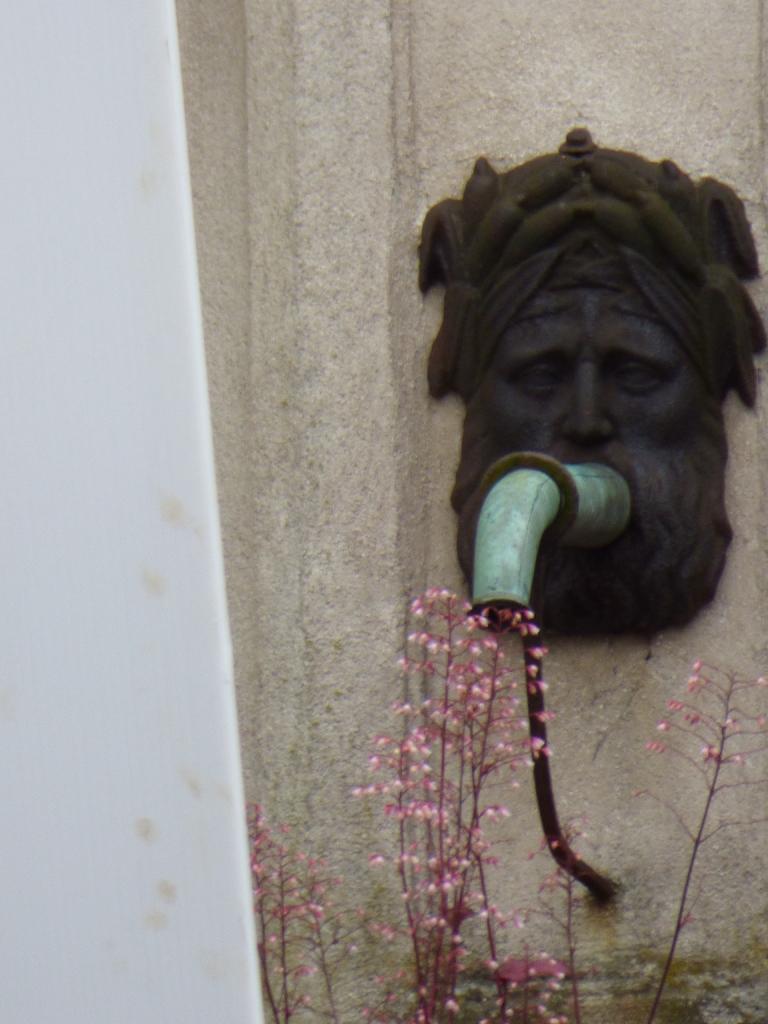How would you summarize this image in a sentence or two? In this image I can see wall, sculpture, pipe, flower plant and objects.  